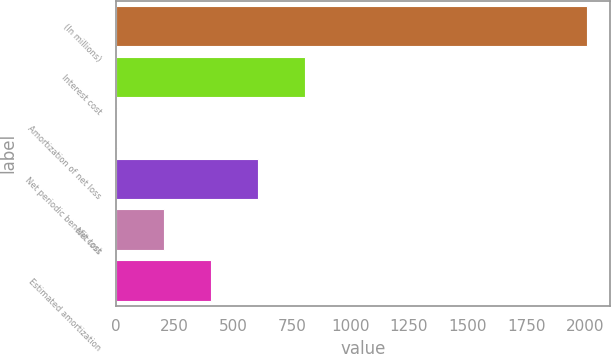Convert chart. <chart><loc_0><loc_0><loc_500><loc_500><bar_chart><fcel>(In millions)<fcel>Interest cost<fcel>Amortization of net loss<fcel>Net periodic benefit cost<fcel>Net loss<fcel>Estimated amortization<nl><fcel>2009<fcel>807.2<fcel>6<fcel>606.9<fcel>206.3<fcel>406.6<nl></chart> 